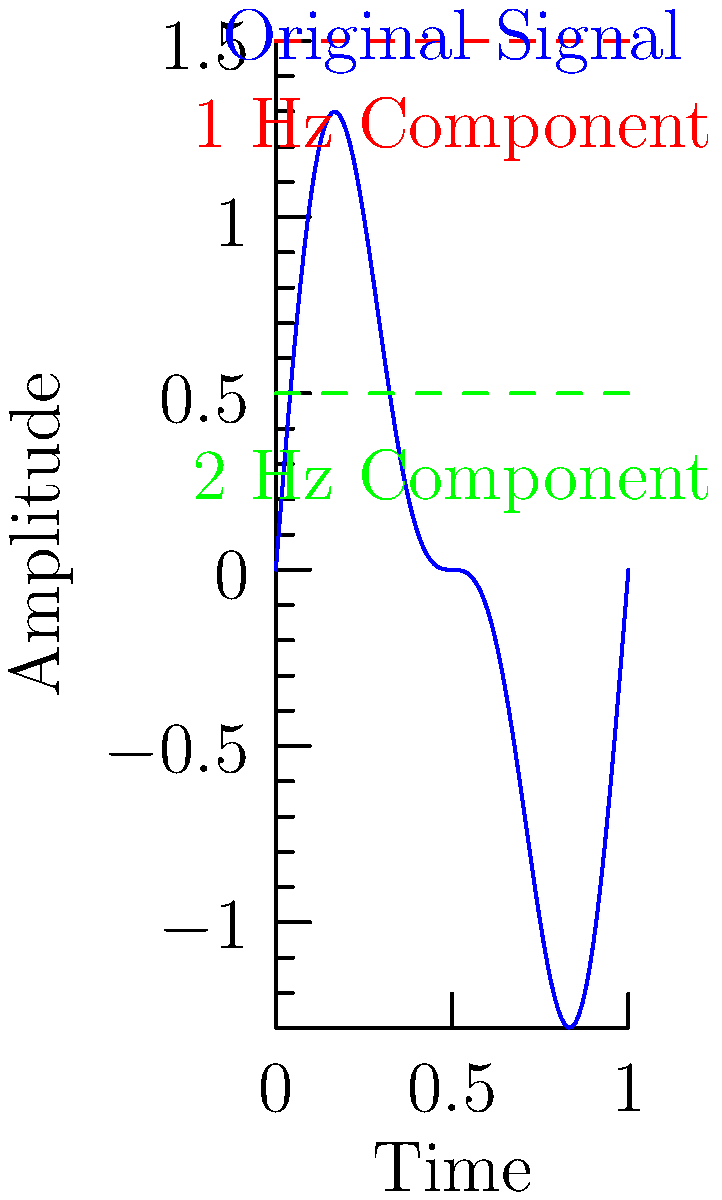As a DJ, you're analyzing a sound wave from a popular sci-fi franchise theme song. The diagram shows the original signal and its frequency components obtained through a Fast Fourier Transform (FFT). What is the fundamental frequency of this signal, and what is the amplitude of its first harmonic? To solve this problem, let's analyze the FFT diagram step-by-step:

1. The blue curve represents the original signal, which is a combination of two sine waves.

2. The FFT has decomposed this signal into its frequency components:
   - The red dashed line represents the fundamental frequency (1 Hz)
   - The green dashed line represents the first harmonic (2 Hz)

3. To find the fundamental frequency:
   - The red line oscillates once over the given time period (0 to 1)
   - Therefore, the fundamental frequency is 1 Hz

4. To find the amplitude of the first harmonic:
   - The green line represents the 2 Hz component (first harmonic)
   - Its peak amplitude is at 0.5 on the y-axis

5. In a typical FFT, the amplitude of each component is half of what's shown in this time-domain representation. However, this is already accounted for in this diagram.

Therefore, the fundamental frequency is 1 Hz, and the amplitude of the first harmonic is 0.5.
Answer: 1 Hz, 0.5 